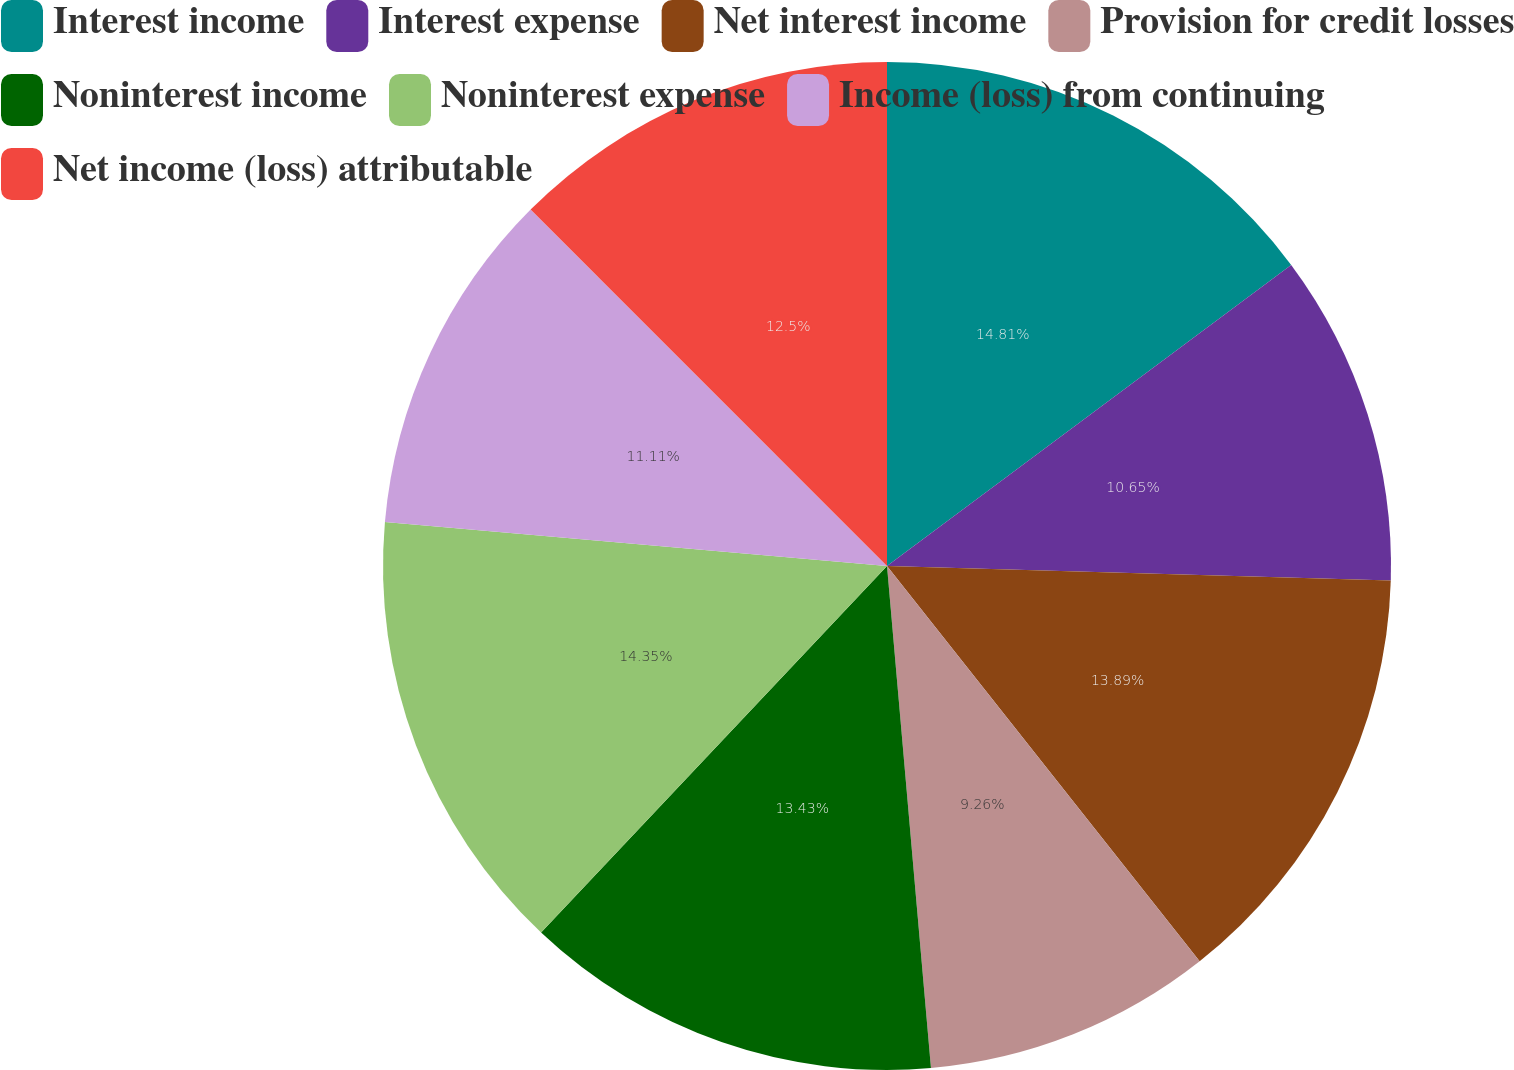<chart> <loc_0><loc_0><loc_500><loc_500><pie_chart><fcel>Interest income<fcel>Interest expense<fcel>Net interest income<fcel>Provision for credit losses<fcel>Noninterest income<fcel>Noninterest expense<fcel>Income (loss) from continuing<fcel>Net income (loss) attributable<nl><fcel>14.81%<fcel>10.65%<fcel>13.89%<fcel>9.26%<fcel>13.43%<fcel>14.35%<fcel>11.11%<fcel>12.5%<nl></chart> 